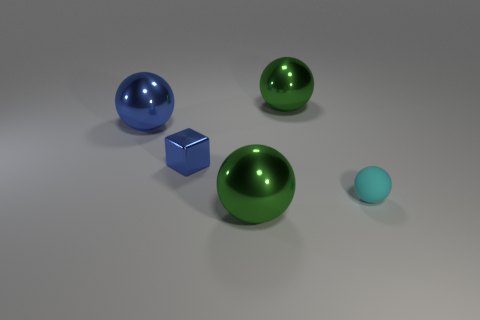Subtract all blue metallic spheres. How many spheres are left? 3 Add 2 large blue balls. How many objects exist? 7 Subtract all green spheres. How many spheres are left? 2 Subtract 2 balls. How many balls are left? 2 Add 3 tiny cyan objects. How many tiny cyan objects are left? 4 Add 1 blue shiny things. How many blue shiny things exist? 3 Subtract 2 green balls. How many objects are left? 3 Subtract all blocks. How many objects are left? 4 Subtract all brown cubes. Subtract all yellow balls. How many cubes are left? 1 Subtract all gray cubes. How many gray balls are left? 0 